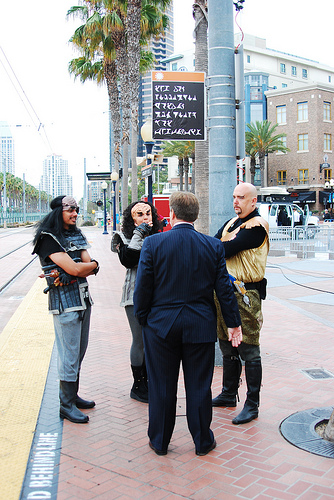<image>
Can you confirm if the man is on the man? No. The man is not positioned on the man. They may be near each other, but the man is not supported by or resting on top of the man. Is the man behind the sign? No. The man is not behind the sign. From this viewpoint, the man appears to be positioned elsewhere in the scene. Is there a man to the right of the man? No. The man is not to the right of the man. The horizontal positioning shows a different relationship. 